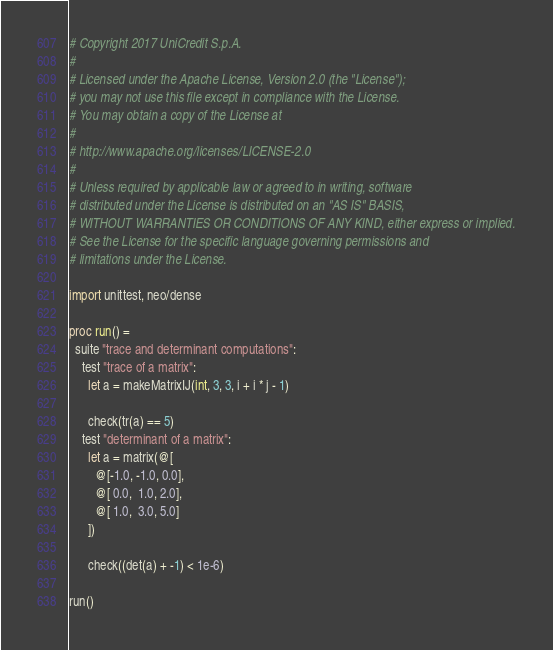Convert code to text. <code><loc_0><loc_0><loc_500><loc_500><_Nim_># Copyright 2017 UniCredit S.p.A.
#
# Licensed under the Apache License, Version 2.0 (the "License");
# you may not use this file except in compliance with the License.
# You may obtain a copy of the License at
#
# http://www.apache.org/licenses/LICENSE-2.0
#
# Unless required by applicable law or agreed to in writing, software
# distributed under the License is distributed on an "AS IS" BASIS,
# WITHOUT WARRANTIES OR CONDITIONS OF ANY KIND, either express or implied.
# See the License for the specific language governing permissions and
# limitations under the License.

import unittest, neo/dense

proc run() =
  suite "trace and determinant computations":
    test "trace of a matrix":
      let a = makeMatrixIJ(int, 3, 3, i + i * j - 1)

      check(tr(a) == 5)
    test "determinant of a matrix":
      let a = matrix(@[
        @[-1.0, -1.0, 0.0],
        @[ 0.0,  1.0, 2.0],
        @[ 1.0,  3.0, 5.0]
      ])

      check((det(a) + -1) < 1e-6)

run()</code> 